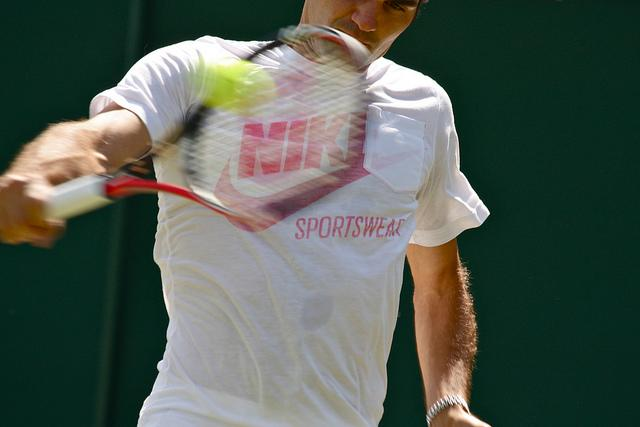Which country houses the headquarter of the brand company manufacturing the man's shirt?

Choices:
A) united states
B) italy
C) britain
D) france united states 